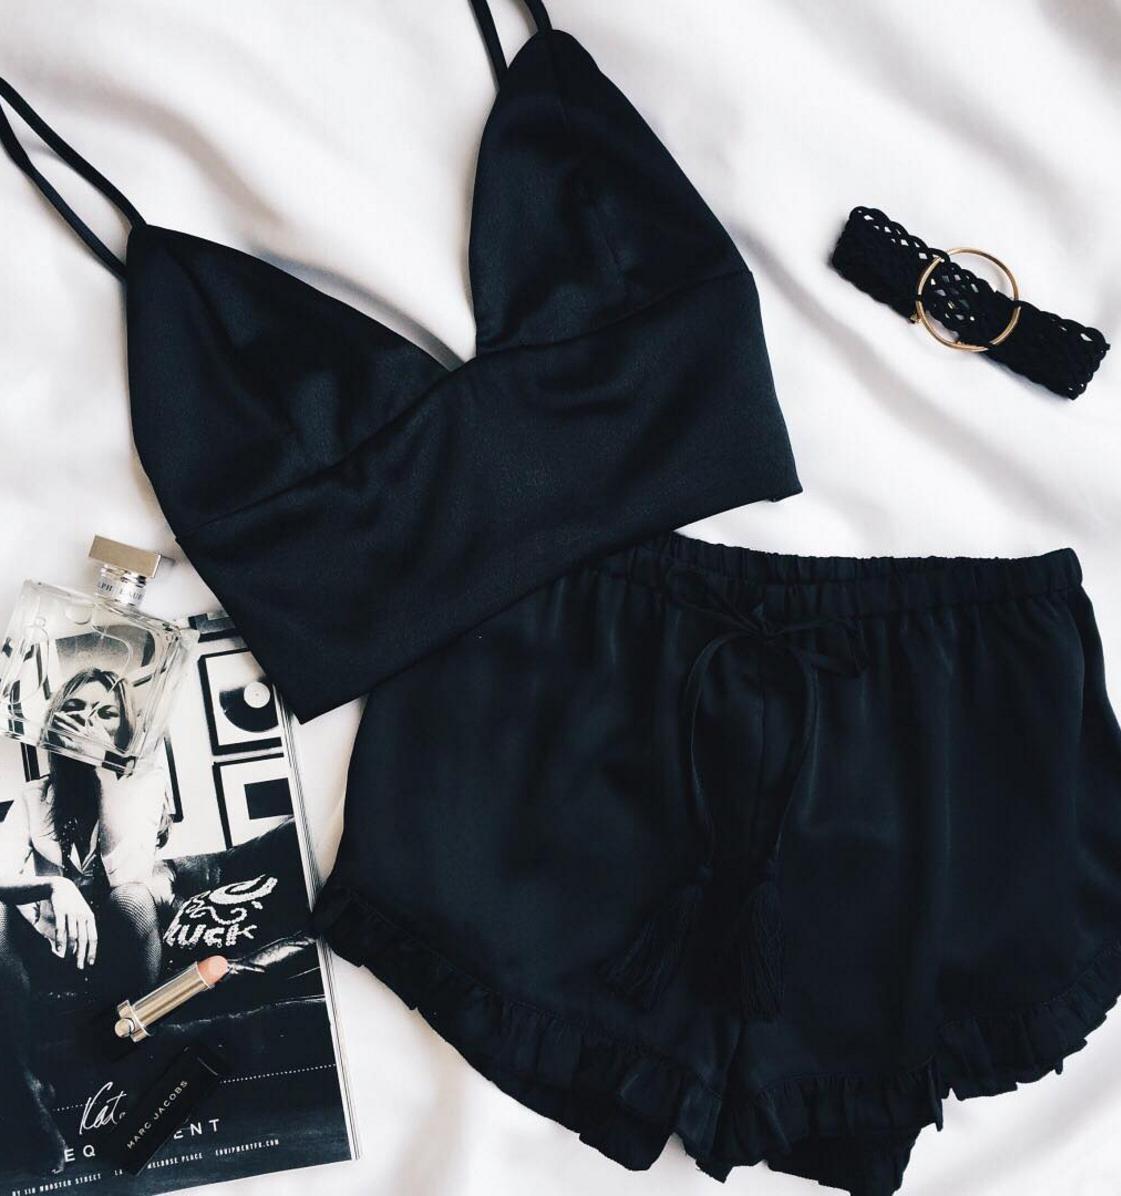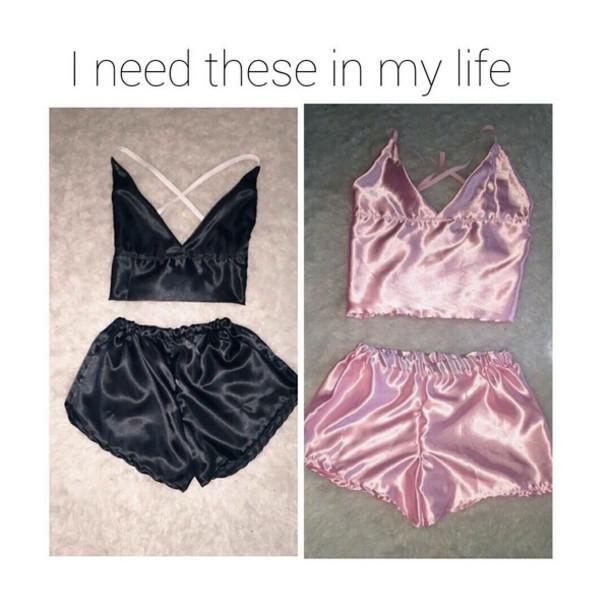The first image is the image on the left, the second image is the image on the right. For the images shown, is this caption "the left image has a necklace and shoes" true? Answer yes or no. No. The first image is the image on the left, the second image is the image on the right. Examine the images to the left and right. Is the description "There are two sets of female pajamas - one of which is of the color gold." accurate? Answer yes or no. No. 